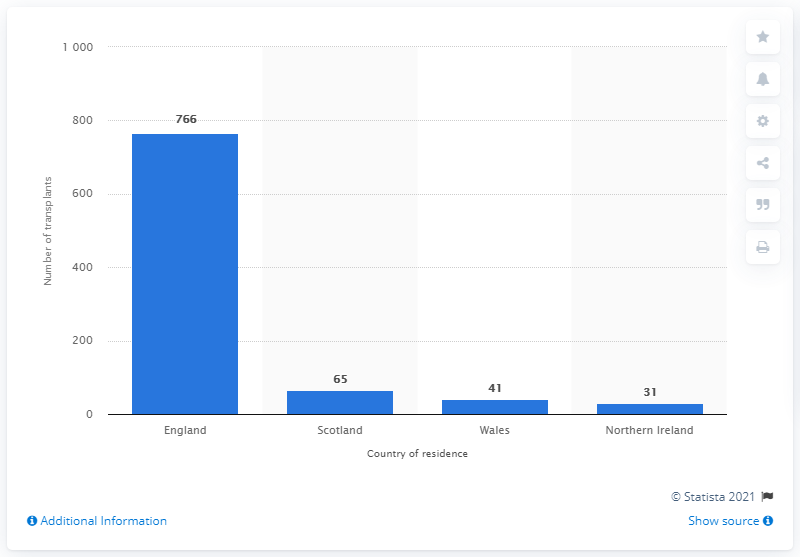Identify some key points in this picture. In the 2019/2020 fiscal year, a total of 65 liver transplants were performed in Scotland. In the 2019/2020 fiscal year, a total of 766 liver transplants were performed in England. 